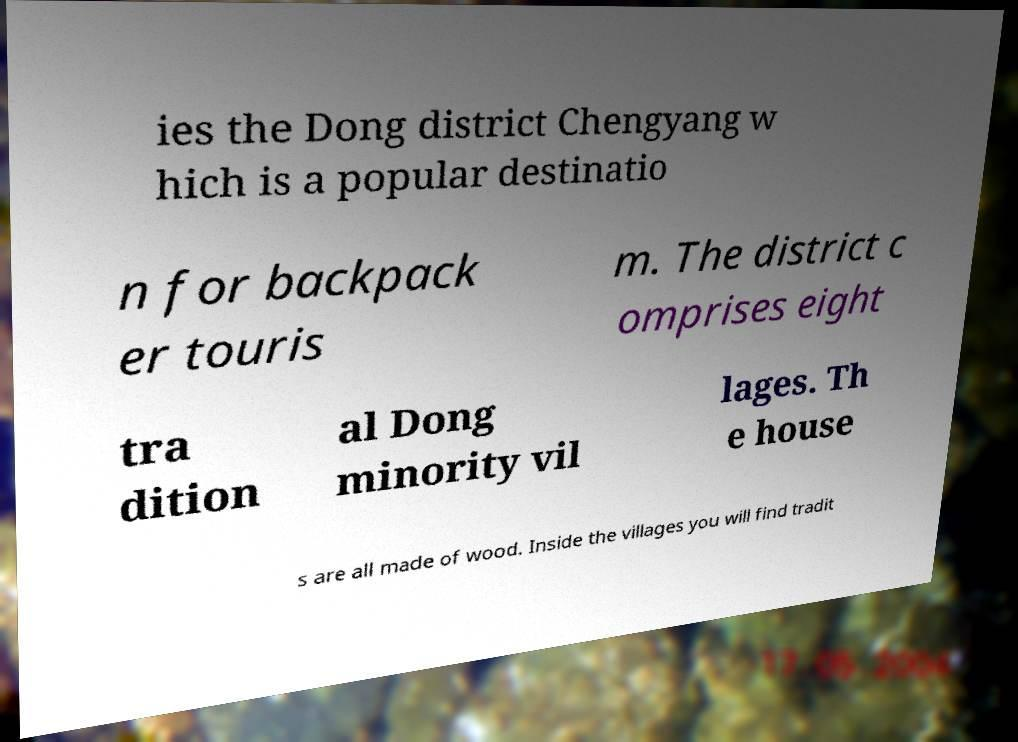For documentation purposes, I need the text within this image transcribed. Could you provide that? ies the Dong district Chengyang w hich is a popular destinatio n for backpack er touris m. The district c omprises eight tra dition al Dong minority vil lages. Th e house s are all made of wood. Inside the villages you will find tradit 